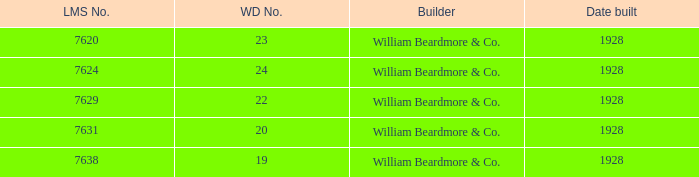Name the builder for serial number being 377 William Beardmore & Co. 